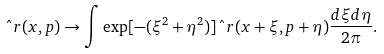<formula> <loc_0><loc_0><loc_500><loc_500>\hat { \ } r ( x , p ) \rightarrow \int \exp [ - ( \xi ^ { 2 } + \eta ^ { 2 } ) ] \hat { \ } r ( x + \xi , p + \eta ) \frac { d \xi d \eta } { 2 \pi } .</formula> 